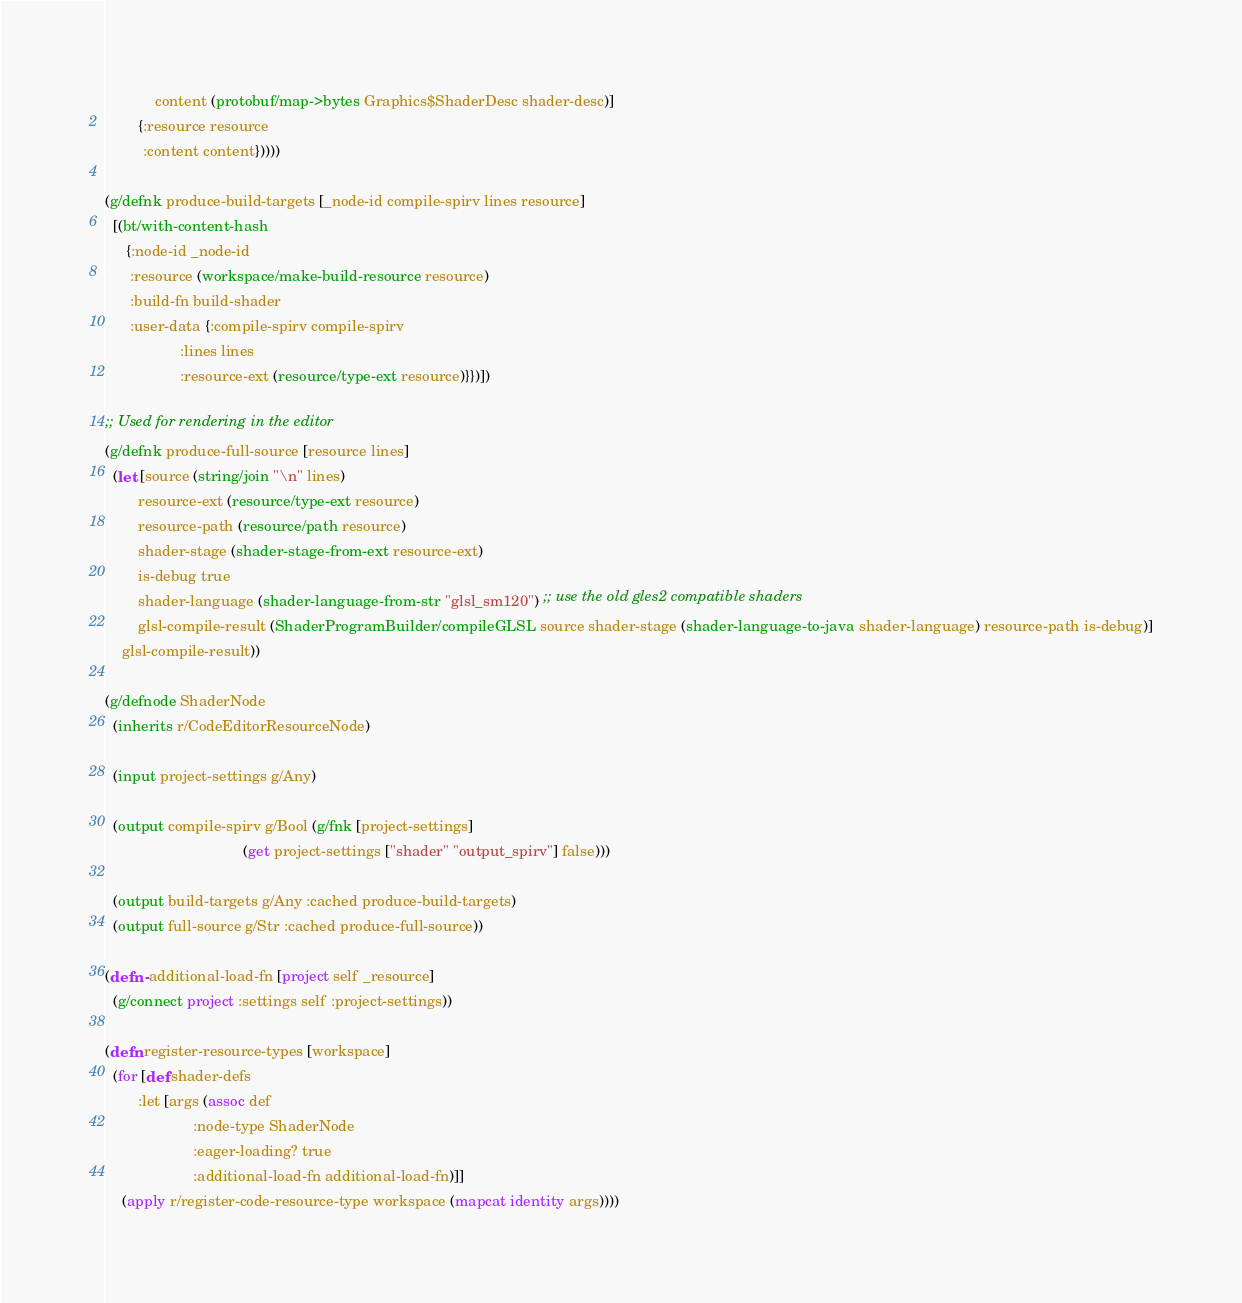<code> <loc_0><loc_0><loc_500><loc_500><_Clojure_>            content (protobuf/map->bytes Graphics$ShaderDesc shader-desc)]
        {:resource resource
         :content content}))))

(g/defnk produce-build-targets [_node-id compile-spirv lines resource]
  [(bt/with-content-hash
     {:node-id _node-id
      :resource (workspace/make-build-resource resource)
      :build-fn build-shader
      :user-data {:compile-spirv compile-spirv
                  :lines lines
                  :resource-ext (resource/type-ext resource)}})])

;; Used for rendering in the editor
(g/defnk produce-full-source [resource lines]
  (let [source (string/join "\n" lines)
        resource-ext (resource/type-ext resource)
        resource-path (resource/path resource)
        shader-stage (shader-stage-from-ext resource-ext)
        is-debug true
        shader-language (shader-language-from-str "glsl_sm120") ;; use the old gles2 compatible shaders
        glsl-compile-result (ShaderProgramBuilder/compileGLSL source shader-stage (shader-language-to-java shader-language) resource-path is-debug)]
    glsl-compile-result))

(g/defnode ShaderNode
  (inherits r/CodeEditorResourceNode)

  (input project-settings g/Any)

  (output compile-spirv g/Bool (g/fnk [project-settings]
                                 (get project-settings ["shader" "output_spirv"] false)))

  (output build-targets g/Any :cached produce-build-targets)
  (output full-source g/Str :cached produce-full-source))

(defn- additional-load-fn [project self _resource]
  (g/connect project :settings self :project-settings))

(defn register-resource-types [workspace]
  (for [def shader-defs
        :let [args (assoc def
                     :node-type ShaderNode
                     :eager-loading? true
                     :additional-load-fn additional-load-fn)]]
    (apply r/register-code-resource-type workspace (mapcat identity args))))
</code> 